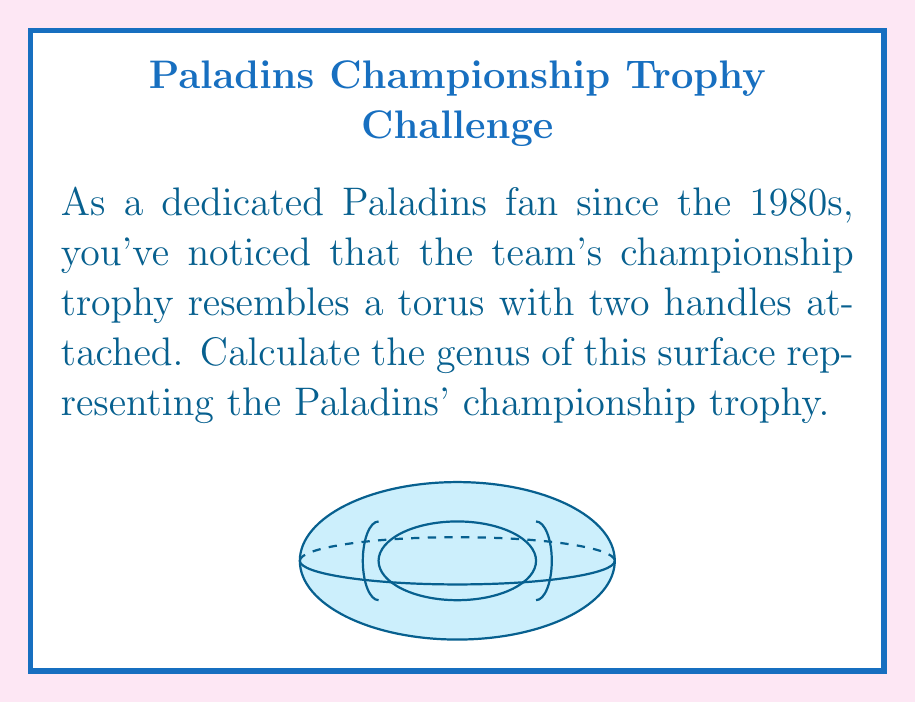Can you solve this math problem? To calculate the genus of the surface representing the Paladins' championship trophy, we need to follow these steps:

1) Recall that the genus of a surface is the number of handles or "holes" it has.

2) In this case, we have a torus (which already has one handle) with two additional handles attached.

3) Let's break it down:
   - A torus has a genus of 1
   - Each additional handle increases the genus by 1

4) Therefore, we can calculate the total genus as follows:
   
   $$g = g_{torus} + g_{additional handles}$$
   $$g = 1 + 2 = 3$$

5) We can also verify this using the Euler characteristic formula:
   
   $$\chi = 2 - 2g$$

   Where $\chi$ is the Euler characteristic and $g$ is the genus.

6) For a surface of genus 3, the Euler characteristic would be:
   
   $$\chi = 2 - 2(3) = -4$$

This confirms our calculation that the genus of the surface is indeed 3.
Answer: 3 